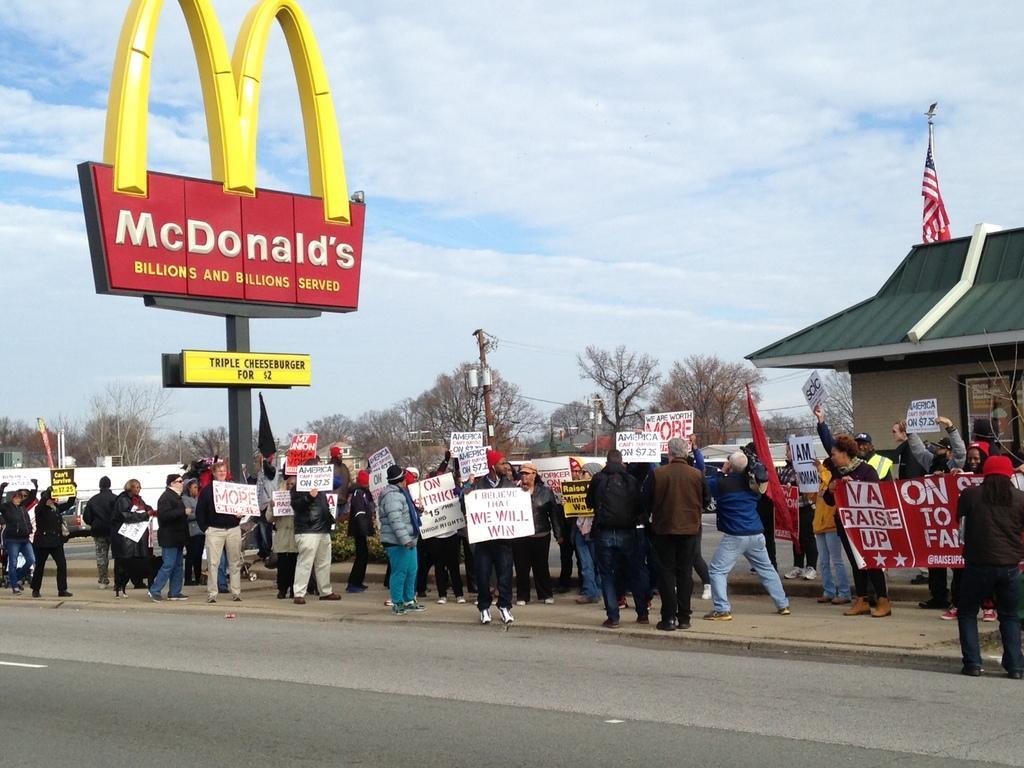Can you describe this image briefly? In this image, at the bottom there are many people, some are holding banners, some are holding posters, charts. At the bottom there is a road. In the background there are trees, house, flag, poles, text board, logo, sky and clouds. 